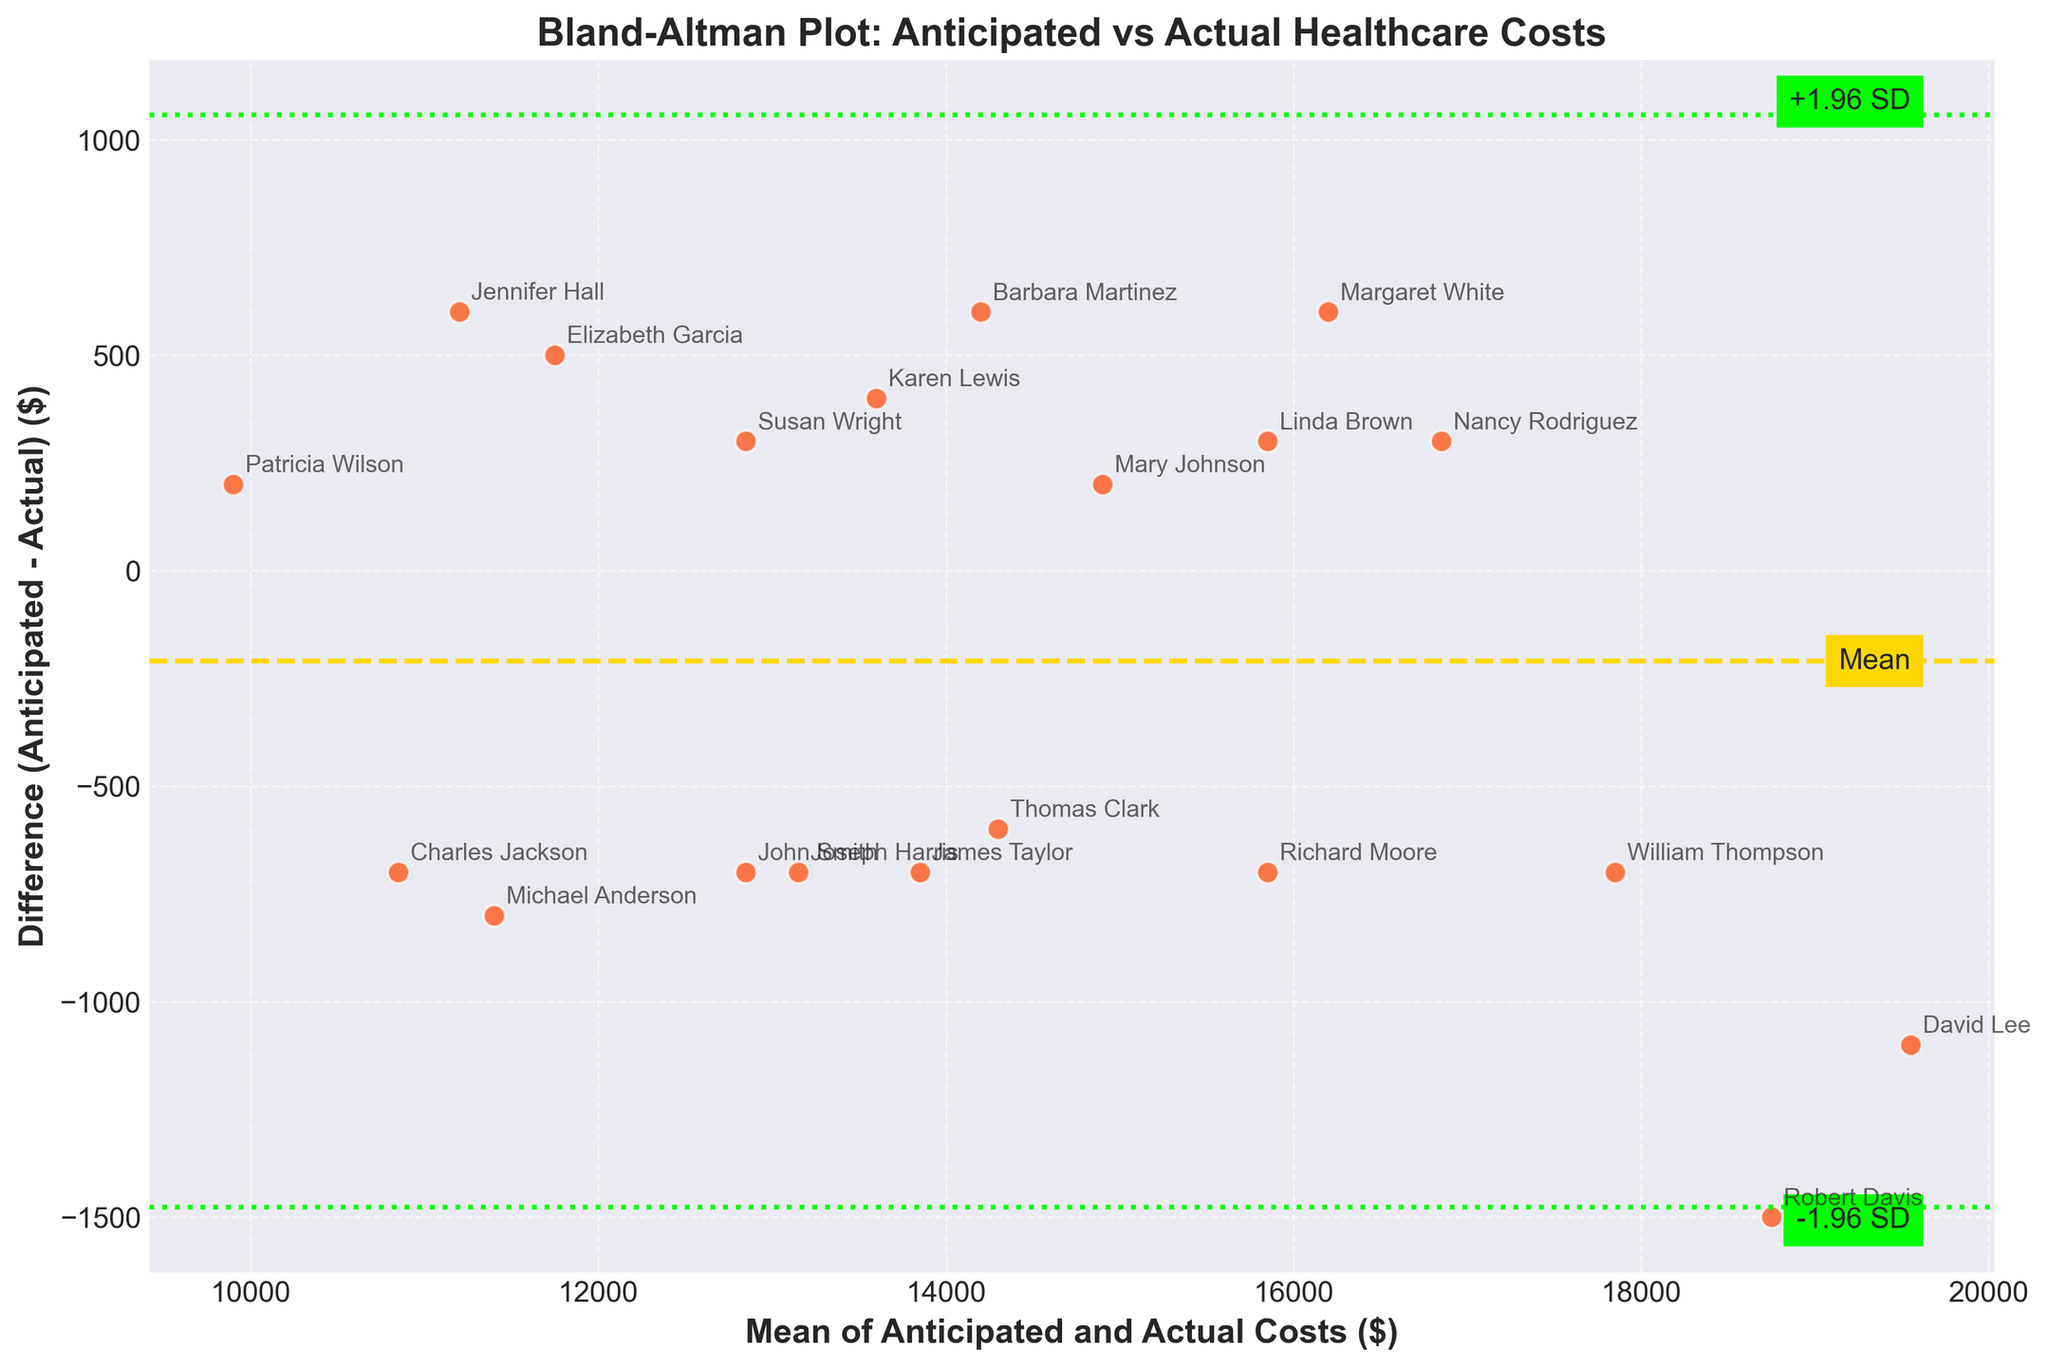What is the title of the figure? The title is displayed prominently at the top of the plot. It reads "Bland-Altman Plot: Anticipated vs Actual Healthcare Costs."
Answer: Bland-Altman Plot: Anticipated vs Actual Healthcare Costs What do the x-axis and y-axis represent? The x-axis represents the mean of anticipated and actual healthcare costs, and the y-axis represents the difference between anticipated and actual healthcare costs.
Answer: Mean of Anticipated and Actual Costs, Difference (Anticipated - Actual) How many data points are there in the plot? Each scatter point represents a retiree, and there are 20 retirees listed in the data. Therefore, there are 20 data points in the plot.
Answer: 20 Which data point shows the largest absolute difference? To find the largest absolute difference, we look at the scatter points farthest from the x-axis (y=0). The retiree with the largest absolute difference appears to be Robert Davis.
Answer: Robert Davis What is the range of the differences shown (from the highest to the lowest value)? The highest difference point (above the mean line) approximates 1500 (Anticipated - Actual for Robert Davis) and the lowest difference (below the mean line) approximates -1000 (Anticipated - Actual for Jennifer Hall).
Answer: -1000 to 1500 What are the values of the mean difference and the standard deviations at which limits are drawn? The mean difference is the middle dashed line (in gold), and the limits are the lines in green. Exact colors aren't specified numerically, but the positioning provides the values. The mean difference looks approximately around 0, and ±1.96 standard deviations are calculated from the data.
Answer: Mean: ~0, +1.96 SD: ~1000, -1.96 SD: ~-1000 Are there more anticipated costs higher or lower than actual costs? We can see how many points are above or below the zero-difference line. There are more points (12) below zero indicating more anticipated costs are lower than actual costs.
Answer: Lower What is the approximate mean value of anticipated and actual costs for the data point representing Mary Johnson? Mary's data dot is located around the mean x-value of 14900. The difference is very small (close to zero).
Answer: 14900 Are there any data points clearly outside the ±1.96 standard deviation lines? A quick look can identify dots beyond these boundary limits. Robert Davis's and Jennifer Hall's points exceed these lines.
Answer: Yes, Robert Davis and Jennifer Hall Which retirees have the smallest difference between anticipated and actual costs? To find the smallest difference, look for points closest to the horizontal zero line. Mary Johnson and Barbara Martinez have very small differences.
Answer: Mary Johnson and Barbara Martinez 